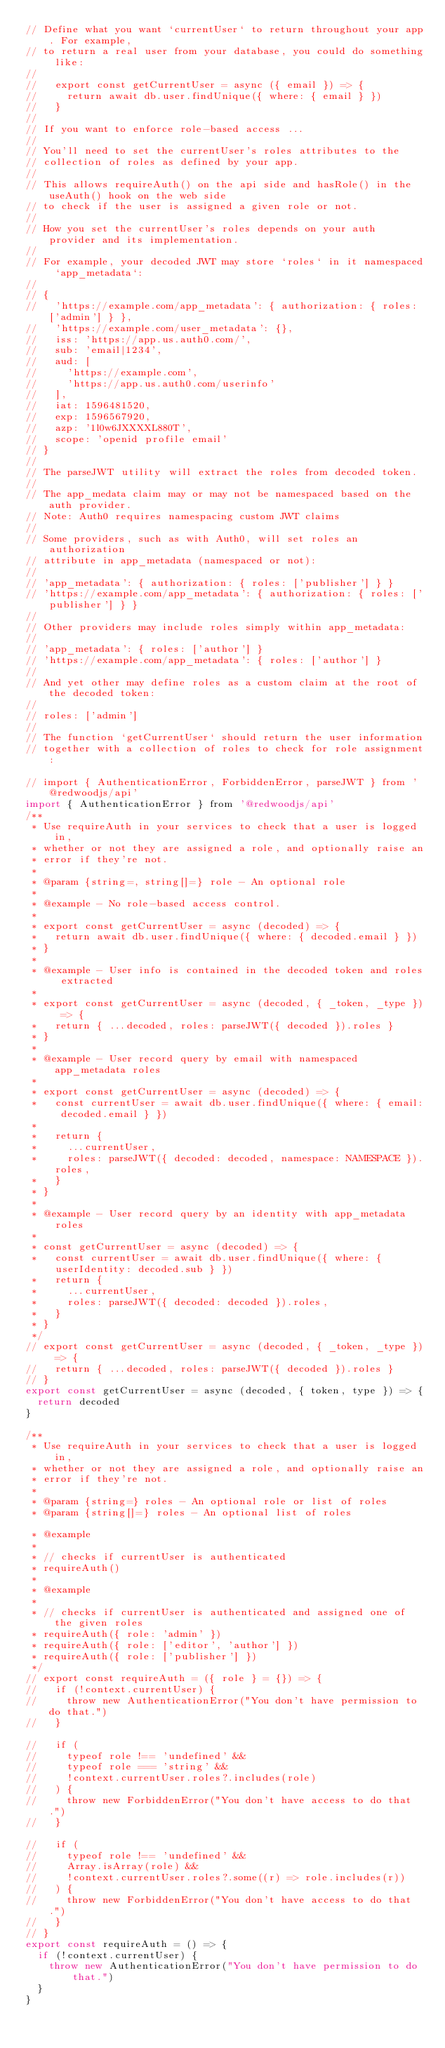Convert code to text. <code><loc_0><loc_0><loc_500><loc_500><_JavaScript_>// Define what you want `currentUser` to return throughout your app. For example,
// to return a real user from your database, you could do something like:
//
//   export const getCurrentUser = async ({ email }) => {
//     return await db.user.findUnique({ where: { email } })
//   }
//
// If you want to enforce role-based access ...
//
// You'll need to set the currentUser's roles attributes to the
// collection of roles as defined by your app.
//
// This allows requireAuth() on the api side and hasRole() in the useAuth() hook on the web side
// to check if the user is assigned a given role or not.
//
// How you set the currentUser's roles depends on your auth provider and its implementation.
//
// For example, your decoded JWT may store `roles` in it namespaced `app_metadata`:
//
// {
//   'https://example.com/app_metadata': { authorization: { roles: ['admin'] } },
//   'https://example.com/user_metadata': {},
//   iss: 'https://app.us.auth0.com/',
//   sub: 'email|1234',
//   aud: [
//     'https://example.com',
//     'https://app.us.auth0.com/userinfo'
//   ],
//   iat: 1596481520,
//   exp: 1596567920,
//   azp: '1l0w6JXXXXL880T',
//   scope: 'openid profile email'
// }
//
// The parseJWT utility will extract the roles from decoded token.
//
// The app_medata claim may or may not be namespaced based on the auth provider.
// Note: Auth0 requires namespacing custom JWT claims
//
// Some providers, such as with Auth0, will set roles an authorization
// attribute in app_metadata (namespaced or not):
//
// 'app_metadata': { authorization: { roles: ['publisher'] } }
// 'https://example.com/app_metadata': { authorization: { roles: ['publisher'] } }
//
// Other providers may include roles simply within app_metadata:
//
// 'app_metadata': { roles: ['author'] }
// 'https://example.com/app_metadata': { roles: ['author'] }
//
// And yet other may define roles as a custom claim at the root of the decoded token:
//
// roles: ['admin']
//
// The function `getCurrentUser` should return the user information
// together with a collection of roles to check for role assignment:

// import { AuthenticationError, ForbiddenError, parseJWT } from '@redwoodjs/api'
import { AuthenticationError } from '@redwoodjs/api'
/**
 * Use requireAuth in your services to check that a user is logged in,
 * whether or not they are assigned a role, and optionally raise an
 * error if they're not.
 *
 * @param {string=, string[]=} role - An optional role
 *
 * @example - No role-based access control.
 *
 * export const getCurrentUser = async (decoded) => {
 *   return await db.user.findUnique({ where: { decoded.email } })
 * }
 *
 * @example - User info is contained in the decoded token and roles extracted
 *
 * export const getCurrentUser = async (decoded, { _token, _type }) => {
 *   return { ...decoded, roles: parseJWT({ decoded }).roles }
 * }
 *
 * @example - User record query by email with namespaced app_metadata roles
 *
 * export const getCurrentUser = async (decoded) => {
 *   const currentUser = await db.user.findUnique({ where: { email: decoded.email } })
 *
 *   return {
 *     ...currentUser,
 *     roles: parseJWT({ decoded: decoded, namespace: NAMESPACE }).roles,
 *   }
 * }
 *
 * @example - User record query by an identity with app_metadata roles
 *
 * const getCurrentUser = async (decoded) => {
 *   const currentUser = await db.user.findUnique({ where: { userIdentity: decoded.sub } })
 *   return {
 *     ...currentUser,
 *     roles: parseJWT({ decoded: decoded }).roles,
 *   }
 * }
 */
// export const getCurrentUser = async (decoded, { _token, _type }) => {
//   return { ...decoded, roles: parseJWT({ decoded }).roles }
// }
export const getCurrentUser = async (decoded, { token, type }) => {
  return decoded
}

/**
 * Use requireAuth in your services to check that a user is logged in,
 * whether or not they are assigned a role, and optionally raise an
 * error if they're not.
 *
 * @param {string=} roles - An optional role or list of roles
 * @param {string[]=} roles - An optional list of roles

 * @example
 *
 * // checks if currentUser is authenticated
 * requireAuth()
 *
 * @example
 *
 * // checks if currentUser is authenticated and assigned one of the given roles
 * requireAuth({ role: 'admin' })
 * requireAuth({ role: ['editor', 'author'] })
 * requireAuth({ role: ['publisher'] })
 */
// export const requireAuth = ({ role } = {}) => {
//   if (!context.currentUser) {
//     throw new AuthenticationError("You don't have permission to do that.")
//   }

//   if (
//     typeof role !== 'undefined' &&
//     typeof role === 'string' &&
//     !context.currentUser.roles?.includes(role)
//   ) {
//     throw new ForbiddenError("You don't have access to do that.")
//   }

//   if (
//     typeof role !== 'undefined' &&
//     Array.isArray(role) &&
//     !context.currentUser.roles?.some((r) => role.includes(r))
//   ) {
//     throw new ForbiddenError("You don't have access to do that.")
//   }
// }
export const requireAuth = () => {
  if (!context.currentUser) {
    throw new AuthenticationError("You don't have permission to do that.")
  }
}
</code> 